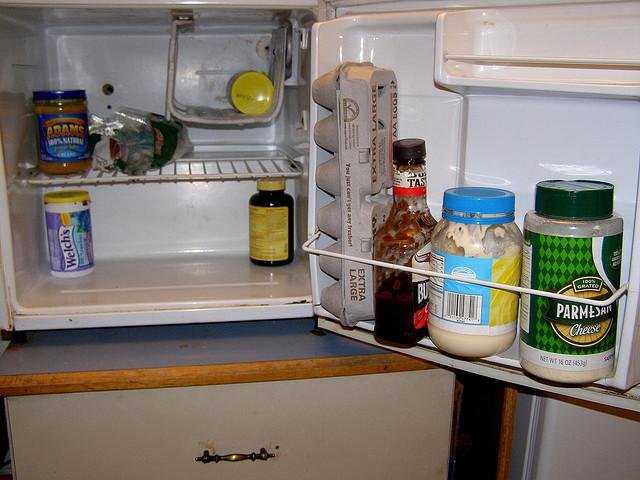How many objects here contain items from the dairy group?

Choices:
A) four
B) three
C) one
D) two three 